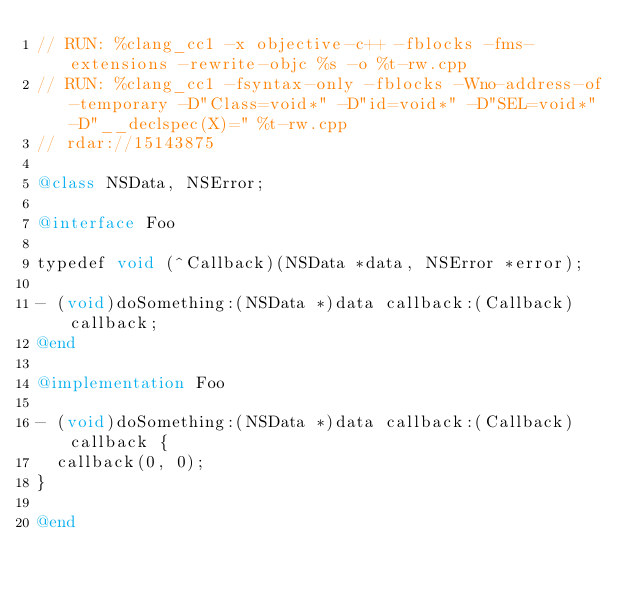Convert code to text. <code><loc_0><loc_0><loc_500><loc_500><_ObjectiveC_>// RUN: %clang_cc1 -x objective-c++ -fblocks -fms-extensions -rewrite-objc %s -o %t-rw.cpp
// RUN: %clang_cc1 -fsyntax-only -fblocks -Wno-address-of-temporary -D"Class=void*" -D"id=void*" -D"SEL=void*" -D"__declspec(X)=" %t-rw.cpp
// rdar://15143875

@class NSData, NSError;

@interface Foo

typedef void (^Callback)(NSData *data, NSError *error);

- (void)doSomething:(NSData *)data callback:(Callback)callback;
@end

@implementation Foo

- (void)doSomething:(NSData *)data callback:(Callback)callback {
  callback(0, 0);
}

@end
</code> 